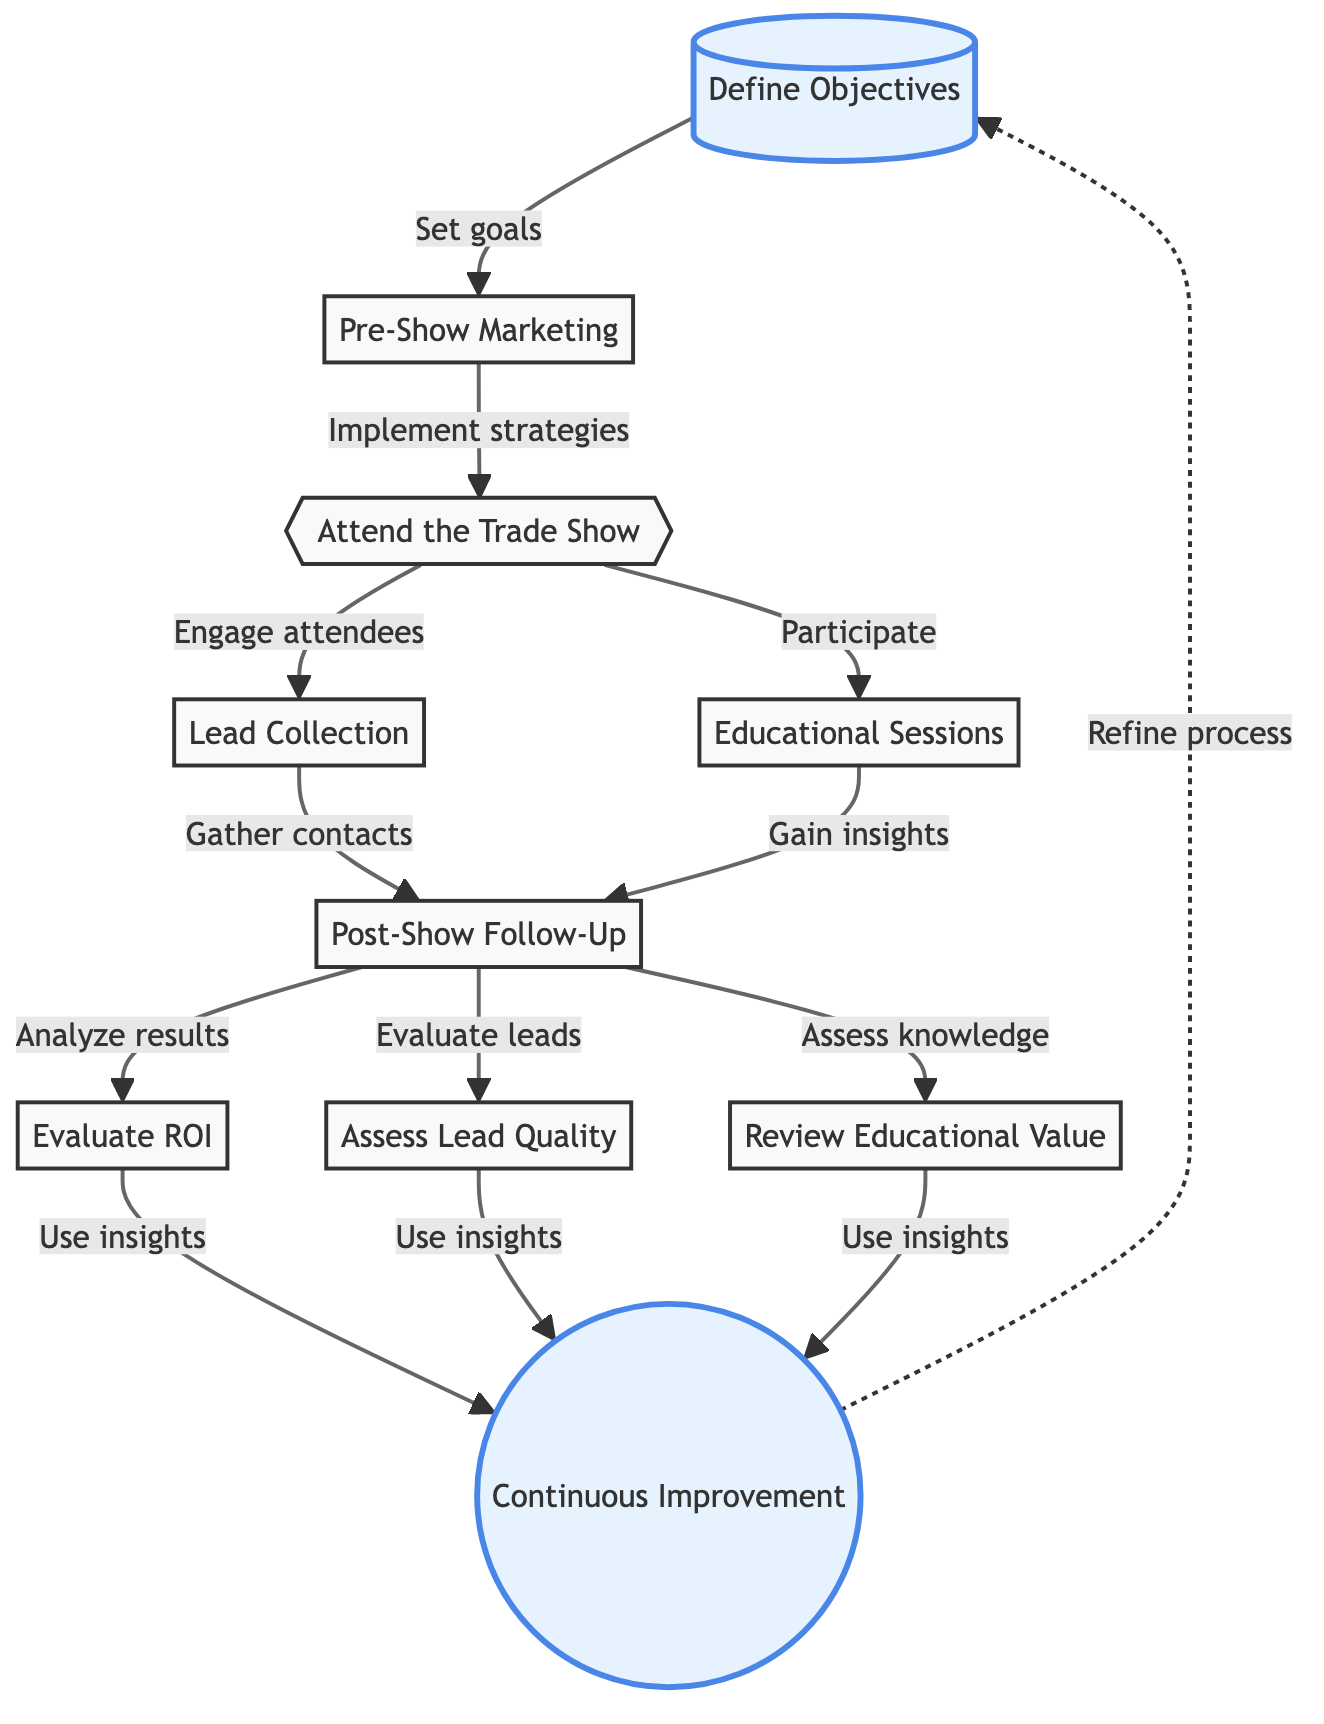What is the first step in the evaluation process? The first step is to "Define Objectives," which involves establishing specific goals for attending the trade show.
Answer: Define Objectives How many nodes are there in the diagram? Counting each individual element represented in the flow chart, there are a total of ten nodes.
Answer: 10 What happens after "Attend the Trade Show"? After "Attend the Trade Show," the next steps are "Lead Collection" and "Educational Sessions," which signify the actions taken during the event.
Answer: Lead Collection, Educational Sessions What is assessed after the "Post-Show Follow-Up"? Following "Post-Show Follow-Up," the processes to "Evaluate ROI," "Assess Lead Quality," and "Review Educational Value" are conducted.
Answer: Evaluate ROI, Assess Lead Quality, Review Educational Value Which step is highlighted in the diagram? The steps highlighted are "Define Objectives" and "Continuous Improvement," indicating their importance in the flow.
Answer: Define Objectives, Continuous Improvement What are the last steps in the evaluation process? The last steps involve "Evaluate ROI," "Assess Lead Quality," and "Review Educational Value," as they assess the outcomes of the trade show participation.
Answer: Evaluate ROI, Assess Lead Quality, Review Educational Value How do insights gained affect the process? Insights gained from evaluating the outcomes are used for "Continuous Improvement," which feeds back to "Define Objectives" for future events.
Answer: Continuous Improvement What connects "Lead Collection" and "Post-Show Follow-Up"? "Lead Collection" leads directly to "Post-Show Follow-Up," indicating that leads gathered must be attended to after the trade show.
Answer: Post-Show Follow-Up 